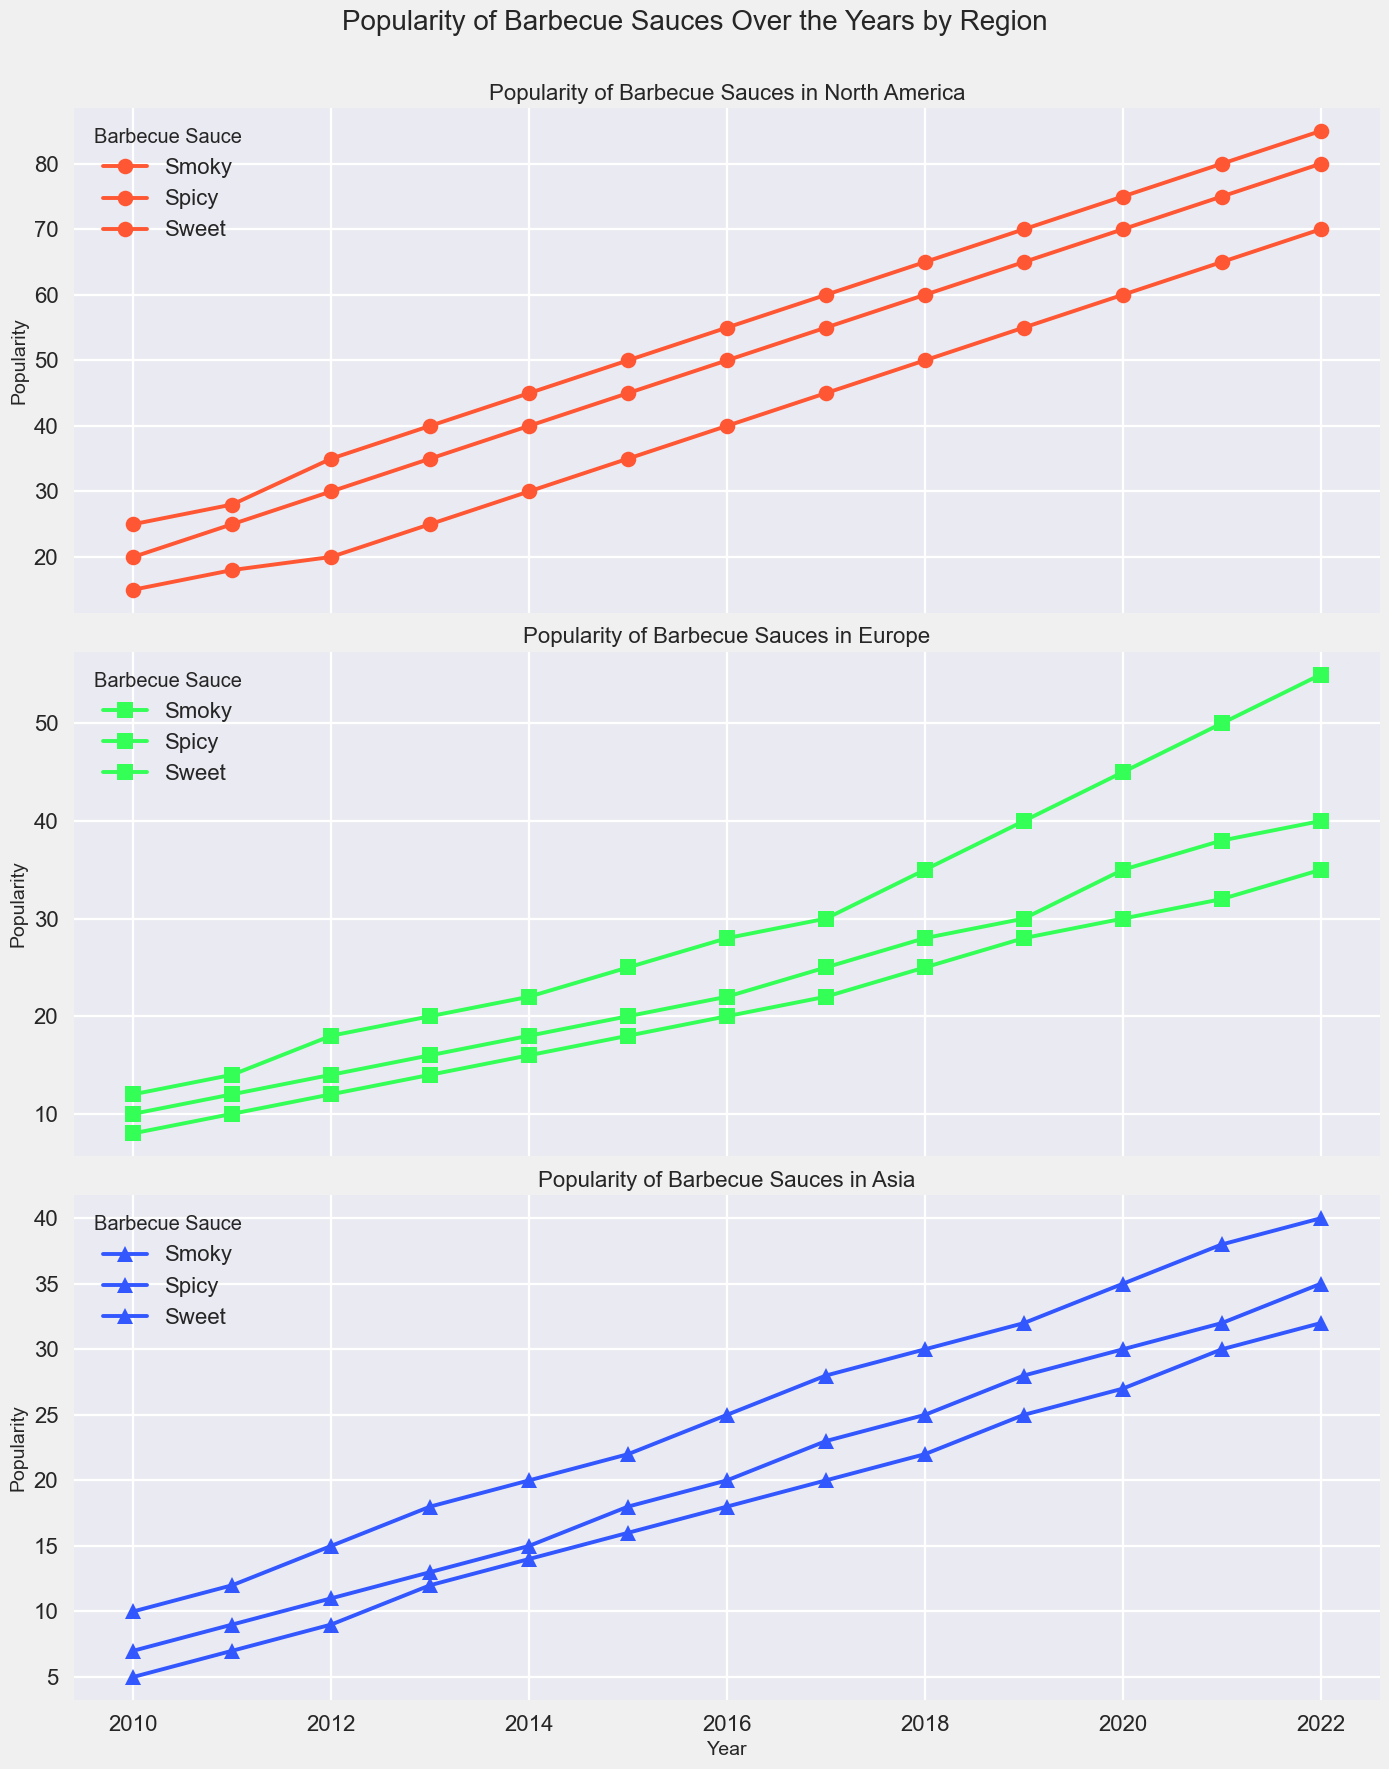Which region saw the steepest increase in the popularity of Smoky barbecue sauce from 2010 to 2022? To determine this, look at the lines representing Smoky sauce for each region and visually assess the slope from 2010 to 2022. North America’s Smoky line rises from 20 to 80, Europe from 10 to 40, and Asia from 5 to 32. North America has the steepest increase.
Answer: North America How does the popularity of Spicy barbecue sauce in Asia in 2022 compare to North America in 2011? In 2022, the popularity of Spicy sauce in Asia is 40. In North America in 2011, it is 18. 40 is greater than 18.
Answer: Asia in 2022 is greater than North America in 2011 What is the average popularity of Sweet barbecue sauce in Europe from 2010 to 2022? Calculate the sum of Sweet sauce values in Europe (12 + 14 + 18 + 20 + 22 + 25 + 28 + 30 + 35 + 40 + 45 + 50 + 55) = 394, then divide by the number of years (13). 394/13 ≈ 30.31.
Answer: Approximately 30.31 Compare the popularity trend of Spicy barbecue sauce in North America and Europe from 2010 to 2022. Observe the lines for Spicy sauce in North America and Europe. North America's line starts at 15 and rises to 70, generally increasing. Europe's line starts at 8 and rises to 35, also increasing but at a slower rate. North America's increase is more rapid.
Answer: North America has a steeper increase What color represents the Smoky barbecue sauce across all regions in the plot? Look at the line that is consistently representing Smoky sauce across different subplots for all regions. Observe its color. It is red.
Answer: Red What is the difference in the popularity of Sweet barbecue sauce between Europe and Asia in 2020? In Europe, the popularity of Sweet sauce in 2020 is 45. In Asia, it is 30. The difference is 45 - 30 = 15.
Answer: 15 Which region had the lowest popularity of Spicy barbecue sauce in 2014? Observe the Spicy sauce lines for each region in 2014. Asia has a value of 20, Europe 16, and North America 30. Europe has the lowest value.
Answer: Europe What is the combined popularity of Smoky and Sweet barbecue sauces in North America in 2018? Add the popularity of Smoky (60) and Sweet (65) sauces in North America in 2018. 60 + 65 = 125.
Answer: 125 How many times did Sweet barbecue sauce reach a popularity of 50 or more in Asia from 2010 to 2022? Check the Sweet sauce line in Asia and count the years when its value is 50 or more. There are no instances where it reaches 50 or more.
Answer: 0 What is the visual trend of Spicy barbecue sauce in Asia from 2015 to 2022? Observe the Spicy sauce line in Asia from 2015 (22) to 2022 (40). The line shows an increasing trend throughout these years.
Answer: Increasing 